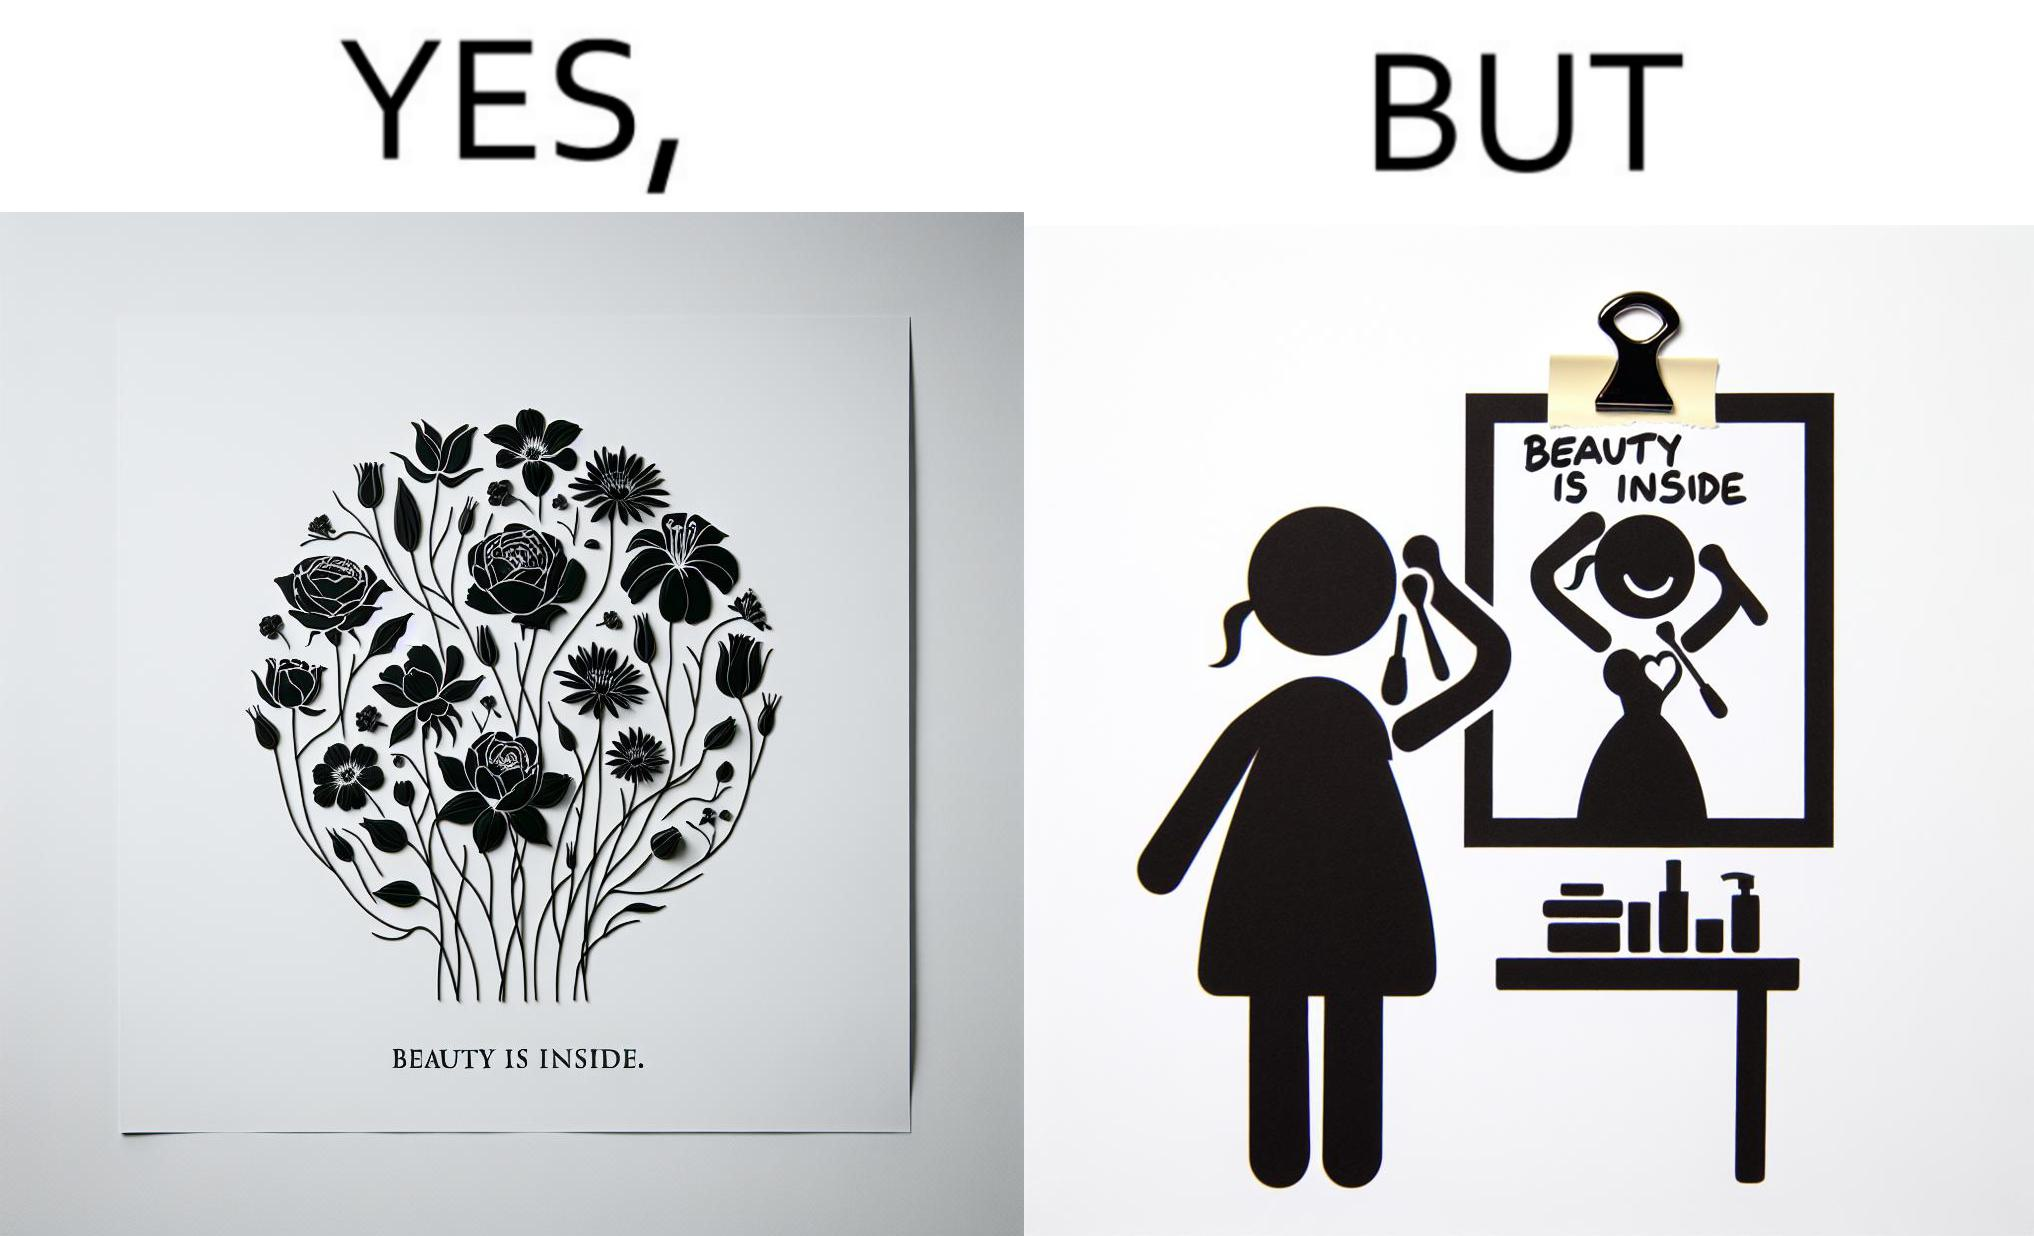Is this image satirical or non-satirical? Yes, this image is satirical. 